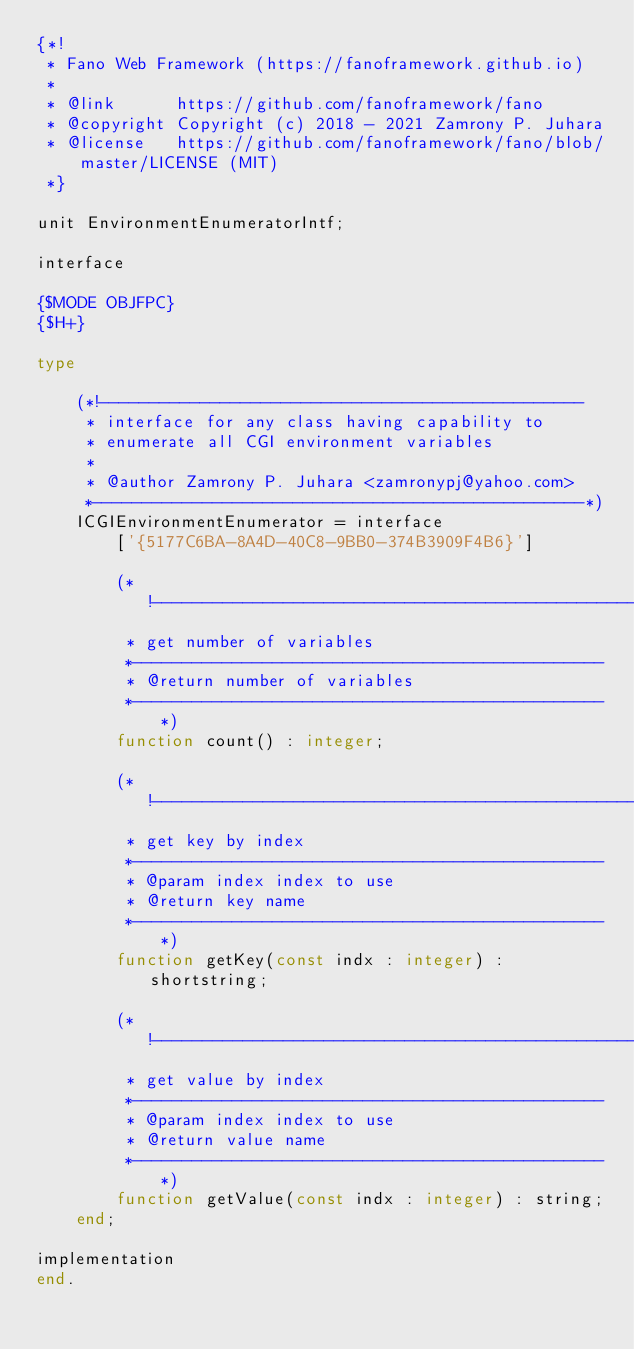<code> <loc_0><loc_0><loc_500><loc_500><_Pascal_>{*!
 * Fano Web Framework (https://fanoframework.github.io)
 *
 * @link      https://github.com/fanoframework/fano
 * @copyright Copyright (c) 2018 - 2021 Zamrony P. Juhara
 * @license   https://github.com/fanoframework/fano/blob/master/LICENSE (MIT)
 *}

unit EnvironmentEnumeratorIntf;

interface

{$MODE OBJFPC}
{$H+}

type

    (*!------------------------------------------------
     * interface for any class having capability to
     * enumerate all CGI environment variables
     *
     * @author Zamrony P. Juhara <zamronypj@yahoo.com>
     *-------------------------------------------------*)
    ICGIEnvironmentEnumerator = interface
        ['{5177C6BA-8A4D-40C8-9BB0-374B3909F4B6}']

        (*!------------------------------------------------
         * get number of variables
         *-----------------------------------------------
         * @return number of variables
         *-----------------------------------------------*)
        function count() : integer;

        (*!------------------------------------------------
         * get key by index
         *-----------------------------------------------
         * @param index index to use
         * @return key name
         *-----------------------------------------------*)
        function getKey(const indx : integer) : shortstring;

        (*!------------------------------------------------
         * get value by index
         *-----------------------------------------------
         * @param index index to use
         * @return value name
         *-----------------------------------------------*)
        function getValue(const indx : integer) : string;
    end;

implementation
end.
</code> 